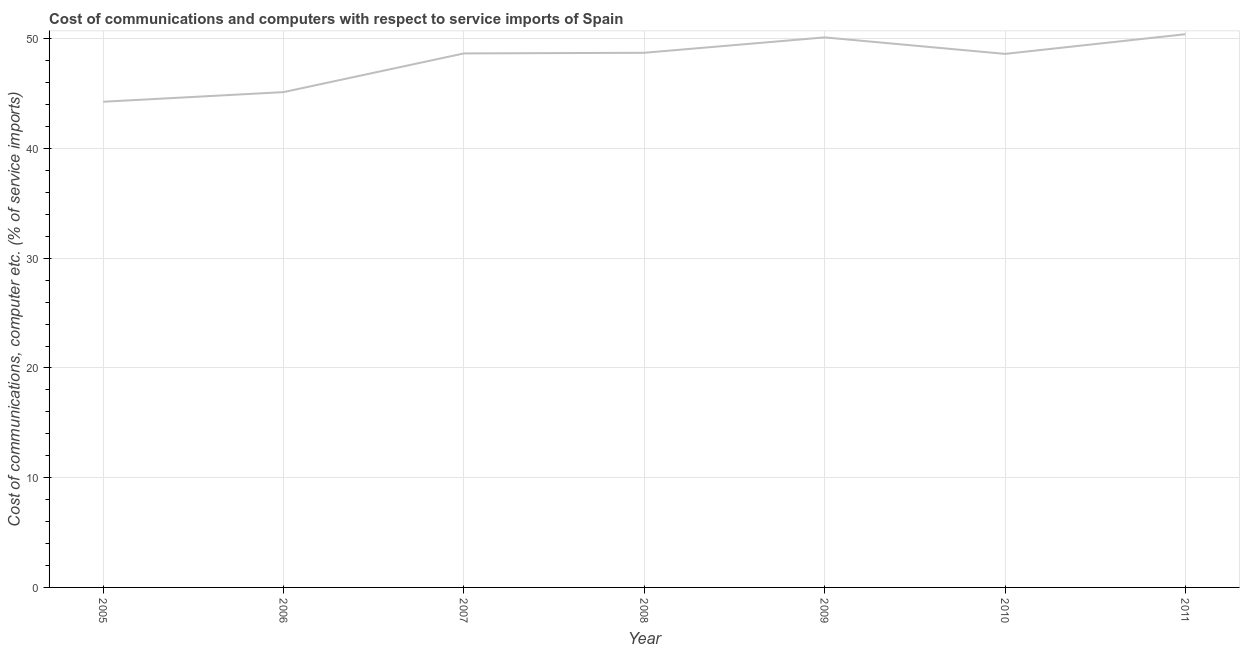What is the cost of communications and computer in 2010?
Your answer should be compact. 48.63. Across all years, what is the maximum cost of communications and computer?
Ensure brevity in your answer.  50.42. Across all years, what is the minimum cost of communications and computer?
Your response must be concise. 44.27. In which year was the cost of communications and computer maximum?
Offer a terse response. 2011. What is the sum of the cost of communications and computer?
Provide a succinct answer. 335.99. What is the difference between the cost of communications and computer in 2008 and 2010?
Offer a terse response. 0.1. What is the average cost of communications and computer per year?
Offer a terse response. 48. What is the median cost of communications and computer?
Offer a terse response. 48.67. What is the ratio of the cost of communications and computer in 2010 to that in 2011?
Your answer should be very brief. 0.96. Is the cost of communications and computer in 2005 less than that in 2011?
Provide a succinct answer. Yes. Is the difference between the cost of communications and computer in 2006 and 2007 greater than the difference between any two years?
Your answer should be compact. No. What is the difference between the highest and the second highest cost of communications and computer?
Your response must be concise. 0.29. Is the sum of the cost of communications and computer in 2005 and 2011 greater than the maximum cost of communications and computer across all years?
Keep it short and to the point. Yes. What is the difference between the highest and the lowest cost of communications and computer?
Give a very brief answer. 6.16. Does the cost of communications and computer monotonically increase over the years?
Provide a short and direct response. No. How many lines are there?
Your response must be concise. 1. What is the difference between two consecutive major ticks on the Y-axis?
Provide a succinct answer. 10. Are the values on the major ticks of Y-axis written in scientific E-notation?
Offer a terse response. No. Does the graph contain any zero values?
Give a very brief answer. No. What is the title of the graph?
Provide a short and direct response. Cost of communications and computers with respect to service imports of Spain. What is the label or title of the Y-axis?
Offer a very short reply. Cost of communications, computer etc. (% of service imports). What is the Cost of communications, computer etc. (% of service imports) in 2005?
Your response must be concise. 44.27. What is the Cost of communications, computer etc. (% of service imports) in 2006?
Your answer should be very brief. 45.14. What is the Cost of communications, computer etc. (% of service imports) of 2007?
Your response must be concise. 48.67. What is the Cost of communications, computer etc. (% of service imports) of 2008?
Keep it short and to the point. 48.73. What is the Cost of communications, computer etc. (% of service imports) of 2009?
Keep it short and to the point. 50.13. What is the Cost of communications, computer etc. (% of service imports) of 2010?
Provide a short and direct response. 48.63. What is the Cost of communications, computer etc. (% of service imports) of 2011?
Offer a terse response. 50.42. What is the difference between the Cost of communications, computer etc. (% of service imports) in 2005 and 2006?
Offer a very short reply. -0.88. What is the difference between the Cost of communications, computer etc. (% of service imports) in 2005 and 2007?
Ensure brevity in your answer.  -4.4. What is the difference between the Cost of communications, computer etc. (% of service imports) in 2005 and 2008?
Your response must be concise. -4.46. What is the difference between the Cost of communications, computer etc. (% of service imports) in 2005 and 2009?
Your answer should be very brief. -5.86. What is the difference between the Cost of communications, computer etc. (% of service imports) in 2005 and 2010?
Provide a succinct answer. -4.36. What is the difference between the Cost of communications, computer etc. (% of service imports) in 2005 and 2011?
Your response must be concise. -6.16. What is the difference between the Cost of communications, computer etc. (% of service imports) in 2006 and 2007?
Your answer should be very brief. -3.53. What is the difference between the Cost of communications, computer etc. (% of service imports) in 2006 and 2008?
Your answer should be very brief. -3.58. What is the difference between the Cost of communications, computer etc. (% of service imports) in 2006 and 2009?
Provide a succinct answer. -4.99. What is the difference between the Cost of communications, computer etc. (% of service imports) in 2006 and 2010?
Your response must be concise. -3.48. What is the difference between the Cost of communications, computer etc. (% of service imports) in 2006 and 2011?
Provide a short and direct response. -5.28. What is the difference between the Cost of communications, computer etc. (% of service imports) in 2007 and 2008?
Your response must be concise. -0.06. What is the difference between the Cost of communications, computer etc. (% of service imports) in 2007 and 2009?
Offer a very short reply. -1.46. What is the difference between the Cost of communications, computer etc. (% of service imports) in 2007 and 2010?
Offer a very short reply. 0.04. What is the difference between the Cost of communications, computer etc. (% of service imports) in 2007 and 2011?
Ensure brevity in your answer.  -1.75. What is the difference between the Cost of communications, computer etc. (% of service imports) in 2008 and 2009?
Offer a very short reply. -1.4. What is the difference between the Cost of communications, computer etc. (% of service imports) in 2008 and 2010?
Make the answer very short. 0.1. What is the difference between the Cost of communications, computer etc. (% of service imports) in 2008 and 2011?
Make the answer very short. -1.69. What is the difference between the Cost of communications, computer etc. (% of service imports) in 2009 and 2010?
Provide a succinct answer. 1.5. What is the difference between the Cost of communications, computer etc. (% of service imports) in 2009 and 2011?
Your response must be concise. -0.29. What is the difference between the Cost of communications, computer etc. (% of service imports) in 2010 and 2011?
Provide a short and direct response. -1.79. What is the ratio of the Cost of communications, computer etc. (% of service imports) in 2005 to that in 2007?
Your response must be concise. 0.91. What is the ratio of the Cost of communications, computer etc. (% of service imports) in 2005 to that in 2008?
Provide a short and direct response. 0.91. What is the ratio of the Cost of communications, computer etc. (% of service imports) in 2005 to that in 2009?
Ensure brevity in your answer.  0.88. What is the ratio of the Cost of communications, computer etc. (% of service imports) in 2005 to that in 2010?
Offer a very short reply. 0.91. What is the ratio of the Cost of communications, computer etc. (% of service imports) in 2005 to that in 2011?
Keep it short and to the point. 0.88. What is the ratio of the Cost of communications, computer etc. (% of service imports) in 2006 to that in 2007?
Provide a succinct answer. 0.93. What is the ratio of the Cost of communications, computer etc. (% of service imports) in 2006 to that in 2008?
Provide a succinct answer. 0.93. What is the ratio of the Cost of communications, computer etc. (% of service imports) in 2006 to that in 2009?
Give a very brief answer. 0.9. What is the ratio of the Cost of communications, computer etc. (% of service imports) in 2006 to that in 2010?
Your response must be concise. 0.93. What is the ratio of the Cost of communications, computer etc. (% of service imports) in 2006 to that in 2011?
Keep it short and to the point. 0.9. What is the ratio of the Cost of communications, computer etc. (% of service imports) in 2007 to that in 2010?
Your answer should be compact. 1. What is the ratio of the Cost of communications, computer etc. (% of service imports) in 2008 to that in 2011?
Keep it short and to the point. 0.97. What is the ratio of the Cost of communications, computer etc. (% of service imports) in 2009 to that in 2010?
Your answer should be compact. 1.03. What is the ratio of the Cost of communications, computer etc. (% of service imports) in 2009 to that in 2011?
Make the answer very short. 0.99. What is the ratio of the Cost of communications, computer etc. (% of service imports) in 2010 to that in 2011?
Ensure brevity in your answer.  0.96. 